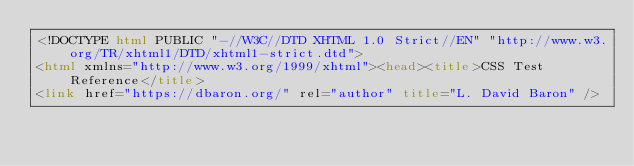Convert code to text. <code><loc_0><loc_0><loc_500><loc_500><_HTML_><!DOCTYPE html PUBLIC "-//W3C//DTD XHTML 1.0 Strict//EN" "http://www.w3.org/TR/xhtml1/DTD/xhtml1-strict.dtd">
<html xmlns="http://www.w3.org/1999/xhtml"><head><title>CSS Test Reference</title>
<link href="https://dbaron.org/" rel="author" title="L. David Baron" /></code> 